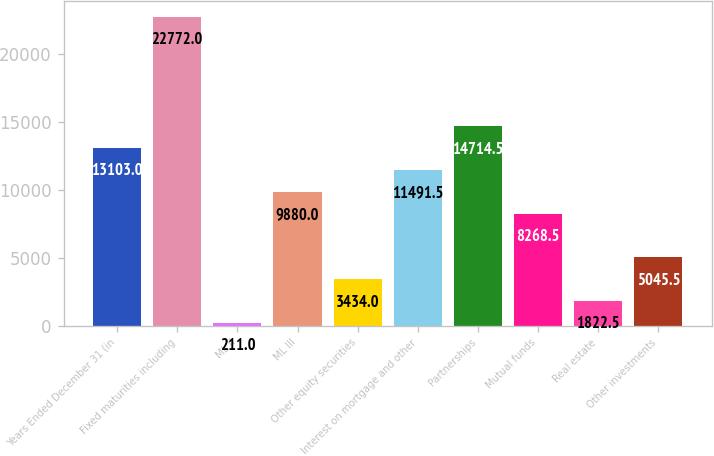Convert chart. <chart><loc_0><loc_0><loc_500><loc_500><bar_chart><fcel>Years Ended December 31 (in<fcel>Fixed maturities including<fcel>ML II<fcel>ML III<fcel>Other equity securities<fcel>Interest on mortgage and other<fcel>Partnerships<fcel>Mutual funds<fcel>Real estate<fcel>Other investments<nl><fcel>13103<fcel>22772<fcel>211<fcel>9880<fcel>3434<fcel>11491.5<fcel>14714.5<fcel>8268.5<fcel>1822.5<fcel>5045.5<nl></chart> 